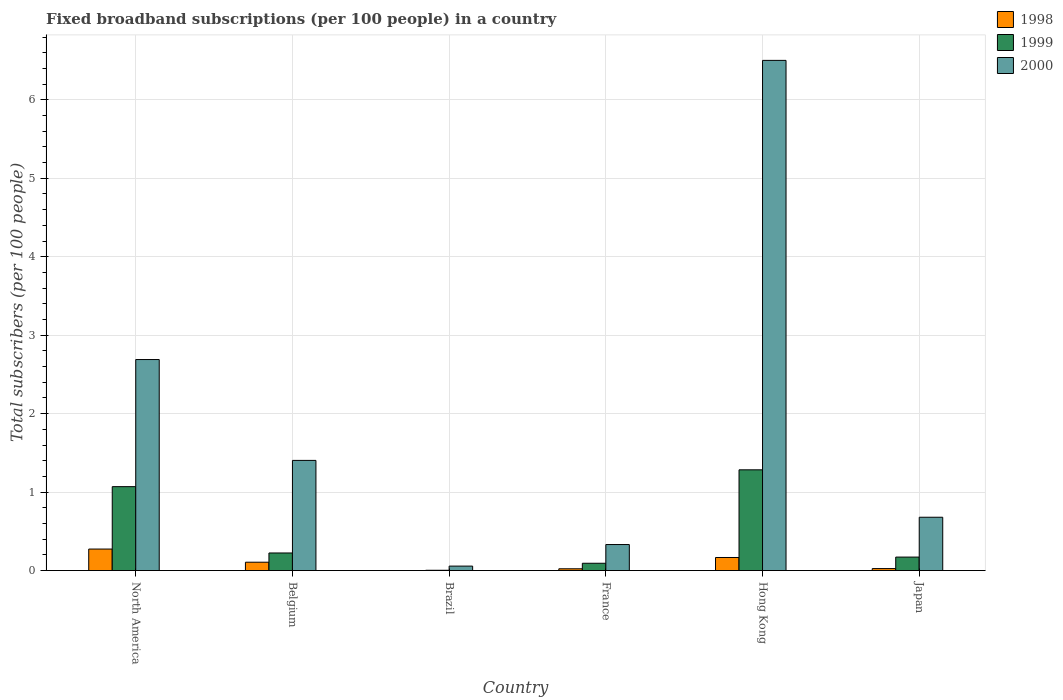Are the number of bars on each tick of the X-axis equal?
Provide a short and direct response. Yes. What is the label of the 5th group of bars from the left?
Offer a terse response. Hong Kong. What is the number of broadband subscriptions in 1999 in France?
Provide a succinct answer. 0.09. Across all countries, what is the maximum number of broadband subscriptions in 2000?
Provide a succinct answer. 6.5. Across all countries, what is the minimum number of broadband subscriptions in 1998?
Offer a terse response. 0. In which country was the number of broadband subscriptions in 2000 maximum?
Keep it short and to the point. Hong Kong. What is the total number of broadband subscriptions in 1999 in the graph?
Offer a terse response. 2.85. What is the difference between the number of broadband subscriptions in 1999 in Belgium and that in Hong Kong?
Ensure brevity in your answer.  -1.06. What is the difference between the number of broadband subscriptions in 1998 in Japan and the number of broadband subscriptions in 1999 in North America?
Your response must be concise. -1.04. What is the average number of broadband subscriptions in 2000 per country?
Make the answer very short. 1.94. What is the difference between the number of broadband subscriptions of/in 2000 and number of broadband subscriptions of/in 1998 in North America?
Give a very brief answer. 2.42. In how many countries, is the number of broadband subscriptions in 1999 greater than 2.2?
Ensure brevity in your answer.  0. What is the ratio of the number of broadband subscriptions in 1998 in Japan to that in North America?
Provide a succinct answer. 0.09. Is the number of broadband subscriptions in 1998 in Belgium less than that in France?
Offer a very short reply. No. What is the difference between the highest and the second highest number of broadband subscriptions in 2000?
Your response must be concise. -1.29. What is the difference between the highest and the lowest number of broadband subscriptions in 1999?
Your answer should be compact. 1.28. In how many countries, is the number of broadband subscriptions in 1999 greater than the average number of broadband subscriptions in 1999 taken over all countries?
Your response must be concise. 2. What does the 3rd bar from the right in Hong Kong represents?
Your response must be concise. 1998. Is it the case that in every country, the sum of the number of broadband subscriptions in 1999 and number of broadband subscriptions in 1998 is greater than the number of broadband subscriptions in 2000?
Your answer should be very brief. No. How many bars are there?
Ensure brevity in your answer.  18. Are all the bars in the graph horizontal?
Keep it short and to the point. No. How many countries are there in the graph?
Make the answer very short. 6. What is the difference between two consecutive major ticks on the Y-axis?
Offer a very short reply. 1. Are the values on the major ticks of Y-axis written in scientific E-notation?
Provide a succinct answer. No. Does the graph contain any zero values?
Ensure brevity in your answer.  No. Where does the legend appear in the graph?
Your answer should be compact. Top right. How are the legend labels stacked?
Your response must be concise. Vertical. What is the title of the graph?
Offer a very short reply. Fixed broadband subscriptions (per 100 people) in a country. What is the label or title of the X-axis?
Provide a short and direct response. Country. What is the label or title of the Y-axis?
Ensure brevity in your answer.  Total subscribers (per 100 people). What is the Total subscribers (per 100 people) of 1998 in North America?
Provide a short and direct response. 0.27. What is the Total subscribers (per 100 people) of 1999 in North America?
Your answer should be compact. 1.07. What is the Total subscribers (per 100 people) in 2000 in North America?
Your answer should be compact. 2.69. What is the Total subscribers (per 100 people) of 1998 in Belgium?
Keep it short and to the point. 0.11. What is the Total subscribers (per 100 people) in 1999 in Belgium?
Give a very brief answer. 0.22. What is the Total subscribers (per 100 people) of 2000 in Belgium?
Ensure brevity in your answer.  1.4. What is the Total subscribers (per 100 people) of 1998 in Brazil?
Your answer should be very brief. 0. What is the Total subscribers (per 100 people) in 1999 in Brazil?
Ensure brevity in your answer.  0. What is the Total subscribers (per 100 people) in 2000 in Brazil?
Provide a short and direct response. 0.06. What is the Total subscribers (per 100 people) in 1998 in France?
Ensure brevity in your answer.  0.02. What is the Total subscribers (per 100 people) in 1999 in France?
Provide a succinct answer. 0.09. What is the Total subscribers (per 100 people) in 2000 in France?
Ensure brevity in your answer.  0.33. What is the Total subscribers (per 100 people) of 1998 in Hong Kong?
Offer a terse response. 0.17. What is the Total subscribers (per 100 people) of 1999 in Hong Kong?
Ensure brevity in your answer.  1.28. What is the Total subscribers (per 100 people) of 2000 in Hong Kong?
Keep it short and to the point. 6.5. What is the Total subscribers (per 100 people) of 1998 in Japan?
Offer a very short reply. 0.03. What is the Total subscribers (per 100 people) in 1999 in Japan?
Provide a short and direct response. 0.17. What is the Total subscribers (per 100 people) in 2000 in Japan?
Your response must be concise. 0.68. Across all countries, what is the maximum Total subscribers (per 100 people) of 1998?
Keep it short and to the point. 0.27. Across all countries, what is the maximum Total subscribers (per 100 people) in 1999?
Keep it short and to the point. 1.28. Across all countries, what is the maximum Total subscribers (per 100 people) of 2000?
Your answer should be compact. 6.5. Across all countries, what is the minimum Total subscribers (per 100 people) of 1998?
Your answer should be very brief. 0. Across all countries, what is the minimum Total subscribers (per 100 people) in 1999?
Your answer should be compact. 0. Across all countries, what is the minimum Total subscribers (per 100 people) in 2000?
Your answer should be compact. 0.06. What is the total Total subscribers (per 100 people) of 1998 in the graph?
Offer a very short reply. 0.6. What is the total Total subscribers (per 100 people) of 1999 in the graph?
Your answer should be very brief. 2.85. What is the total Total subscribers (per 100 people) in 2000 in the graph?
Make the answer very short. 11.67. What is the difference between the Total subscribers (per 100 people) in 1998 in North America and that in Belgium?
Make the answer very short. 0.17. What is the difference between the Total subscribers (per 100 people) of 1999 in North America and that in Belgium?
Your answer should be very brief. 0.85. What is the difference between the Total subscribers (per 100 people) of 2000 in North America and that in Belgium?
Offer a very short reply. 1.29. What is the difference between the Total subscribers (per 100 people) in 1998 in North America and that in Brazil?
Offer a terse response. 0.27. What is the difference between the Total subscribers (per 100 people) in 1999 in North America and that in Brazil?
Make the answer very short. 1.07. What is the difference between the Total subscribers (per 100 people) in 2000 in North America and that in Brazil?
Offer a very short reply. 2.63. What is the difference between the Total subscribers (per 100 people) of 1998 in North America and that in France?
Offer a terse response. 0.25. What is the difference between the Total subscribers (per 100 people) in 1999 in North America and that in France?
Your answer should be very brief. 0.98. What is the difference between the Total subscribers (per 100 people) in 2000 in North America and that in France?
Offer a very short reply. 2.36. What is the difference between the Total subscribers (per 100 people) in 1998 in North America and that in Hong Kong?
Provide a short and direct response. 0.11. What is the difference between the Total subscribers (per 100 people) of 1999 in North America and that in Hong Kong?
Offer a very short reply. -0.21. What is the difference between the Total subscribers (per 100 people) of 2000 in North America and that in Hong Kong?
Your response must be concise. -3.81. What is the difference between the Total subscribers (per 100 people) of 1998 in North America and that in Japan?
Your answer should be compact. 0.25. What is the difference between the Total subscribers (per 100 people) of 1999 in North America and that in Japan?
Ensure brevity in your answer.  0.9. What is the difference between the Total subscribers (per 100 people) in 2000 in North America and that in Japan?
Ensure brevity in your answer.  2.01. What is the difference between the Total subscribers (per 100 people) in 1998 in Belgium and that in Brazil?
Your response must be concise. 0.11. What is the difference between the Total subscribers (per 100 people) of 1999 in Belgium and that in Brazil?
Make the answer very short. 0.22. What is the difference between the Total subscribers (per 100 people) of 2000 in Belgium and that in Brazil?
Ensure brevity in your answer.  1.35. What is the difference between the Total subscribers (per 100 people) in 1998 in Belgium and that in France?
Offer a terse response. 0.08. What is the difference between the Total subscribers (per 100 people) of 1999 in Belgium and that in France?
Offer a very short reply. 0.13. What is the difference between the Total subscribers (per 100 people) in 2000 in Belgium and that in France?
Offer a very short reply. 1.07. What is the difference between the Total subscribers (per 100 people) in 1998 in Belgium and that in Hong Kong?
Your answer should be compact. -0.06. What is the difference between the Total subscribers (per 100 people) of 1999 in Belgium and that in Hong Kong?
Make the answer very short. -1.06. What is the difference between the Total subscribers (per 100 people) of 2000 in Belgium and that in Hong Kong?
Keep it short and to the point. -5.1. What is the difference between the Total subscribers (per 100 people) in 1998 in Belgium and that in Japan?
Provide a short and direct response. 0.08. What is the difference between the Total subscribers (per 100 people) in 1999 in Belgium and that in Japan?
Your answer should be compact. 0.05. What is the difference between the Total subscribers (per 100 people) of 2000 in Belgium and that in Japan?
Offer a very short reply. 0.72. What is the difference between the Total subscribers (per 100 people) in 1998 in Brazil and that in France?
Offer a terse response. -0.02. What is the difference between the Total subscribers (per 100 people) of 1999 in Brazil and that in France?
Give a very brief answer. -0.09. What is the difference between the Total subscribers (per 100 people) in 2000 in Brazil and that in France?
Your response must be concise. -0.27. What is the difference between the Total subscribers (per 100 people) of 1998 in Brazil and that in Hong Kong?
Your answer should be very brief. -0.17. What is the difference between the Total subscribers (per 100 people) of 1999 in Brazil and that in Hong Kong?
Give a very brief answer. -1.28. What is the difference between the Total subscribers (per 100 people) in 2000 in Brazil and that in Hong Kong?
Provide a short and direct response. -6.45. What is the difference between the Total subscribers (per 100 people) in 1998 in Brazil and that in Japan?
Your response must be concise. -0.03. What is the difference between the Total subscribers (per 100 people) of 1999 in Brazil and that in Japan?
Keep it short and to the point. -0.17. What is the difference between the Total subscribers (per 100 people) of 2000 in Brazil and that in Japan?
Offer a very short reply. -0.62. What is the difference between the Total subscribers (per 100 people) in 1998 in France and that in Hong Kong?
Provide a succinct answer. -0.14. What is the difference between the Total subscribers (per 100 people) of 1999 in France and that in Hong Kong?
Offer a very short reply. -1.19. What is the difference between the Total subscribers (per 100 people) in 2000 in France and that in Hong Kong?
Your answer should be compact. -6.17. What is the difference between the Total subscribers (per 100 people) of 1998 in France and that in Japan?
Keep it short and to the point. -0. What is the difference between the Total subscribers (per 100 people) of 1999 in France and that in Japan?
Your answer should be compact. -0.08. What is the difference between the Total subscribers (per 100 people) in 2000 in France and that in Japan?
Offer a very short reply. -0.35. What is the difference between the Total subscribers (per 100 people) in 1998 in Hong Kong and that in Japan?
Your answer should be compact. 0.14. What is the difference between the Total subscribers (per 100 people) in 1999 in Hong Kong and that in Japan?
Give a very brief answer. 1.11. What is the difference between the Total subscribers (per 100 people) in 2000 in Hong Kong and that in Japan?
Your answer should be compact. 5.82. What is the difference between the Total subscribers (per 100 people) of 1998 in North America and the Total subscribers (per 100 people) of 1999 in Belgium?
Your answer should be very brief. 0.05. What is the difference between the Total subscribers (per 100 people) in 1998 in North America and the Total subscribers (per 100 people) in 2000 in Belgium?
Your response must be concise. -1.13. What is the difference between the Total subscribers (per 100 people) of 1999 in North America and the Total subscribers (per 100 people) of 2000 in Belgium?
Keep it short and to the point. -0.33. What is the difference between the Total subscribers (per 100 people) of 1998 in North America and the Total subscribers (per 100 people) of 1999 in Brazil?
Your answer should be compact. 0.27. What is the difference between the Total subscribers (per 100 people) in 1998 in North America and the Total subscribers (per 100 people) in 2000 in Brazil?
Your answer should be compact. 0.22. What is the difference between the Total subscribers (per 100 people) in 1999 in North America and the Total subscribers (per 100 people) in 2000 in Brazil?
Provide a short and direct response. 1.01. What is the difference between the Total subscribers (per 100 people) of 1998 in North America and the Total subscribers (per 100 people) of 1999 in France?
Give a very brief answer. 0.18. What is the difference between the Total subscribers (per 100 people) of 1998 in North America and the Total subscribers (per 100 people) of 2000 in France?
Your answer should be very brief. -0.06. What is the difference between the Total subscribers (per 100 people) of 1999 in North America and the Total subscribers (per 100 people) of 2000 in France?
Offer a very short reply. 0.74. What is the difference between the Total subscribers (per 100 people) in 1998 in North America and the Total subscribers (per 100 people) in 1999 in Hong Kong?
Keep it short and to the point. -1.01. What is the difference between the Total subscribers (per 100 people) of 1998 in North America and the Total subscribers (per 100 people) of 2000 in Hong Kong?
Offer a terse response. -6.23. What is the difference between the Total subscribers (per 100 people) in 1999 in North America and the Total subscribers (per 100 people) in 2000 in Hong Kong?
Give a very brief answer. -5.43. What is the difference between the Total subscribers (per 100 people) of 1998 in North America and the Total subscribers (per 100 people) of 1999 in Japan?
Your answer should be compact. 0.1. What is the difference between the Total subscribers (per 100 people) in 1998 in North America and the Total subscribers (per 100 people) in 2000 in Japan?
Offer a terse response. -0.41. What is the difference between the Total subscribers (per 100 people) of 1999 in North America and the Total subscribers (per 100 people) of 2000 in Japan?
Your response must be concise. 0.39. What is the difference between the Total subscribers (per 100 people) of 1998 in Belgium and the Total subscribers (per 100 people) of 1999 in Brazil?
Give a very brief answer. 0.1. What is the difference between the Total subscribers (per 100 people) of 1998 in Belgium and the Total subscribers (per 100 people) of 2000 in Brazil?
Your answer should be compact. 0.05. What is the difference between the Total subscribers (per 100 people) in 1999 in Belgium and the Total subscribers (per 100 people) in 2000 in Brazil?
Keep it short and to the point. 0.17. What is the difference between the Total subscribers (per 100 people) in 1998 in Belgium and the Total subscribers (per 100 people) in 1999 in France?
Your answer should be very brief. 0.01. What is the difference between the Total subscribers (per 100 people) in 1998 in Belgium and the Total subscribers (per 100 people) in 2000 in France?
Offer a terse response. -0.23. What is the difference between the Total subscribers (per 100 people) of 1999 in Belgium and the Total subscribers (per 100 people) of 2000 in France?
Ensure brevity in your answer.  -0.11. What is the difference between the Total subscribers (per 100 people) in 1998 in Belgium and the Total subscribers (per 100 people) in 1999 in Hong Kong?
Your answer should be very brief. -1.18. What is the difference between the Total subscribers (per 100 people) in 1998 in Belgium and the Total subscribers (per 100 people) in 2000 in Hong Kong?
Your answer should be compact. -6.4. What is the difference between the Total subscribers (per 100 people) of 1999 in Belgium and the Total subscribers (per 100 people) of 2000 in Hong Kong?
Your response must be concise. -6.28. What is the difference between the Total subscribers (per 100 people) in 1998 in Belgium and the Total subscribers (per 100 people) in 1999 in Japan?
Your response must be concise. -0.07. What is the difference between the Total subscribers (per 100 people) in 1998 in Belgium and the Total subscribers (per 100 people) in 2000 in Japan?
Make the answer very short. -0.57. What is the difference between the Total subscribers (per 100 people) in 1999 in Belgium and the Total subscribers (per 100 people) in 2000 in Japan?
Provide a short and direct response. -0.46. What is the difference between the Total subscribers (per 100 people) in 1998 in Brazil and the Total subscribers (per 100 people) in 1999 in France?
Keep it short and to the point. -0.09. What is the difference between the Total subscribers (per 100 people) in 1998 in Brazil and the Total subscribers (per 100 people) in 2000 in France?
Your answer should be compact. -0.33. What is the difference between the Total subscribers (per 100 people) in 1999 in Brazil and the Total subscribers (per 100 people) in 2000 in France?
Ensure brevity in your answer.  -0.33. What is the difference between the Total subscribers (per 100 people) in 1998 in Brazil and the Total subscribers (per 100 people) in 1999 in Hong Kong?
Make the answer very short. -1.28. What is the difference between the Total subscribers (per 100 people) of 1998 in Brazil and the Total subscribers (per 100 people) of 2000 in Hong Kong?
Give a very brief answer. -6.5. What is the difference between the Total subscribers (per 100 people) of 1999 in Brazil and the Total subscribers (per 100 people) of 2000 in Hong Kong?
Offer a terse response. -6.5. What is the difference between the Total subscribers (per 100 people) in 1998 in Brazil and the Total subscribers (per 100 people) in 1999 in Japan?
Keep it short and to the point. -0.17. What is the difference between the Total subscribers (per 100 people) in 1998 in Brazil and the Total subscribers (per 100 people) in 2000 in Japan?
Offer a terse response. -0.68. What is the difference between the Total subscribers (per 100 people) in 1999 in Brazil and the Total subscribers (per 100 people) in 2000 in Japan?
Your response must be concise. -0.68. What is the difference between the Total subscribers (per 100 people) in 1998 in France and the Total subscribers (per 100 people) in 1999 in Hong Kong?
Provide a succinct answer. -1.26. What is the difference between the Total subscribers (per 100 people) in 1998 in France and the Total subscribers (per 100 people) in 2000 in Hong Kong?
Offer a very short reply. -6.48. What is the difference between the Total subscribers (per 100 people) of 1999 in France and the Total subscribers (per 100 people) of 2000 in Hong Kong?
Give a very brief answer. -6.41. What is the difference between the Total subscribers (per 100 people) of 1998 in France and the Total subscribers (per 100 people) of 1999 in Japan?
Your answer should be very brief. -0.15. What is the difference between the Total subscribers (per 100 people) of 1998 in France and the Total subscribers (per 100 people) of 2000 in Japan?
Your answer should be very brief. -0.66. What is the difference between the Total subscribers (per 100 people) of 1999 in France and the Total subscribers (per 100 people) of 2000 in Japan?
Your answer should be very brief. -0.59. What is the difference between the Total subscribers (per 100 people) of 1998 in Hong Kong and the Total subscribers (per 100 people) of 1999 in Japan?
Provide a short and direct response. -0.01. What is the difference between the Total subscribers (per 100 people) of 1998 in Hong Kong and the Total subscribers (per 100 people) of 2000 in Japan?
Your answer should be very brief. -0.51. What is the difference between the Total subscribers (per 100 people) in 1999 in Hong Kong and the Total subscribers (per 100 people) in 2000 in Japan?
Give a very brief answer. 0.6. What is the average Total subscribers (per 100 people) of 1998 per country?
Keep it short and to the point. 0.1. What is the average Total subscribers (per 100 people) in 1999 per country?
Your answer should be very brief. 0.47. What is the average Total subscribers (per 100 people) in 2000 per country?
Your answer should be compact. 1.94. What is the difference between the Total subscribers (per 100 people) of 1998 and Total subscribers (per 100 people) of 1999 in North America?
Provide a short and direct response. -0.8. What is the difference between the Total subscribers (per 100 people) in 1998 and Total subscribers (per 100 people) in 2000 in North America?
Offer a terse response. -2.42. What is the difference between the Total subscribers (per 100 people) in 1999 and Total subscribers (per 100 people) in 2000 in North America?
Ensure brevity in your answer.  -1.62. What is the difference between the Total subscribers (per 100 people) of 1998 and Total subscribers (per 100 people) of 1999 in Belgium?
Provide a succinct answer. -0.12. What is the difference between the Total subscribers (per 100 people) of 1998 and Total subscribers (per 100 people) of 2000 in Belgium?
Give a very brief answer. -1.3. What is the difference between the Total subscribers (per 100 people) in 1999 and Total subscribers (per 100 people) in 2000 in Belgium?
Give a very brief answer. -1.18. What is the difference between the Total subscribers (per 100 people) in 1998 and Total subscribers (per 100 people) in 1999 in Brazil?
Your response must be concise. -0. What is the difference between the Total subscribers (per 100 people) in 1998 and Total subscribers (per 100 people) in 2000 in Brazil?
Give a very brief answer. -0.06. What is the difference between the Total subscribers (per 100 people) in 1999 and Total subscribers (per 100 people) in 2000 in Brazil?
Provide a short and direct response. -0.05. What is the difference between the Total subscribers (per 100 people) in 1998 and Total subscribers (per 100 people) in 1999 in France?
Your response must be concise. -0.07. What is the difference between the Total subscribers (per 100 people) of 1998 and Total subscribers (per 100 people) of 2000 in France?
Offer a terse response. -0.31. What is the difference between the Total subscribers (per 100 people) in 1999 and Total subscribers (per 100 people) in 2000 in France?
Your answer should be compact. -0.24. What is the difference between the Total subscribers (per 100 people) in 1998 and Total subscribers (per 100 people) in 1999 in Hong Kong?
Your answer should be very brief. -1.12. What is the difference between the Total subscribers (per 100 people) of 1998 and Total subscribers (per 100 people) of 2000 in Hong Kong?
Offer a terse response. -6.34. What is the difference between the Total subscribers (per 100 people) in 1999 and Total subscribers (per 100 people) in 2000 in Hong Kong?
Your response must be concise. -5.22. What is the difference between the Total subscribers (per 100 people) of 1998 and Total subscribers (per 100 people) of 1999 in Japan?
Make the answer very short. -0.15. What is the difference between the Total subscribers (per 100 people) in 1998 and Total subscribers (per 100 people) in 2000 in Japan?
Your answer should be very brief. -0.65. What is the difference between the Total subscribers (per 100 people) of 1999 and Total subscribers (per 100 people) of 2000 in Japan?
Ensure brevity in your answer.  -0.51. What is the ratio of the Total subscribers (per 100 people) in 1998 in North America to that in Belgium?
Keep it short and to the point. 2.57. What is the ratio of the Total subscribers (per 100 people) in 1999 in North America to that in Belgium?
Offer a very short reply. 4.76. What is the ratio of the Total subscribers (per 100 people) of 2000 in North America to that in Belgium?
Offer a terse response. 1.92. What is the ratio of the Total subscribers (per 100 people) of 1998 in North America to that in Brazil?
Provide a short and direct response. 465.15. What is the ratio of the Total subscribers (per 100 people) of 1999 in North America to that in Brazil?
Provide a succinct answer. 262.9. What is the ratio of the Total subscribers (per 100 people) of 2000 in North America to that in Brazil?
Offer a terse response. 46.94. What is the ratio of the Total subscribers (per 100 people) in 1998 in North America to that in France?
Keep it short and to the point. 11.95. What is the ratio of the Total subscribers (per 100 people) of 1999 in North America to that in France?
Give a very brief answer. 11.46. What is the ratio of the Total subscribers (per 100 people) of 2000 in North America to that in France?
Your response must be concise. 8.1. What is the ratio of the Total subscribers (per 100 people) of 1998 in North America to that in Hong Kong?
Ensure brevity in your answer.  1.64. What is the ratio of the Total subscribers (per 100 people) of 1999 in North America to that in Hong Kong?
Make the answer very short. 0.83. What is the ratio of the Total subscribers (per 100 people) of 2000 in North America to that in Hong Kong?
Provide a short and direct response. 0.41. What is the ratio of the Total subscribers (per 100 people) of 1998 in North America to that in Japan?
Your answer should be very brief. 10.74. What is the ratio of the Total subscribers (per 100 people) in 1999 in North America to that in Japan?
Make the answer very short. 6.22. What is the ratio of the Total subscribers (per 100 people) of 2000 in North America to that in Japan?
Your response must be concise. 3.96. What is the ratio of the Total subscribers (per 100 people) in 1998 in Belgium to that in Brazil?
Give a very brief answer. 181.1. What is the ratio of the Total subscribers (per 100 people) of 1999 in Belgium to that in Brazil?
Provide a short and direct response. 55.18. What is the ratio of the Total subscribers (per 100 people) in 2000 in Belgium to that in Brazil?
Your response must be concise. 24.51. What is the ratio of the Total subscribers (per 100 people) of 1998 in Belgium to that in France?
Your answer should be compact. 4.65. What is the ratio of the Total subscribers (per 100 people) of 1999 in Belgium to that in France?
Make the answer very short. 2.4. What is the ratio of the Total subscribers (per 100 people) of 2000 in Belgium to that in France?
Provide a short and direct response. 4.23. What is the ratio of the Total subscribers (per 100 people) in 1998 in Belgium to that in Hong Kong?
Offer a very short reply. 0.64. What is the ratio of the Total subscribers (per 100 people) of 1999 in Belgium to that in Hong Kong?
Your answer should be very brief. 0.17. What is the ratio of the Total subscribers (per 100 people) of 2000 in Belgium to that in Hong Kong?
Offer a terse response. 0.22. What is the ratio of the Total subscribers (per 100 people) in 1998 in Belgium to that in Japan?
Offer a terse response. 4.18. What is the ratio of the Total subscribers (per 100 people) of 1999 in Belgium to that in Japan?
Offer a terse response. 1.3. What is the ratio of the Total subscribers (per 100 people) of 2000 in Belgium to that in Japan?
Offer a terse response. 2.07. What is the ratio of the Total subscribers (per 100 people) of 1998 in Brazil to that in France?
Keep it short and to the point. 0.03. What is the ratio of the Total subscribers (per 100 people) of 1999 in Brazil to that in France?
Offer a terse response. 0.04. What is the ratio of the Total subscribers (per 100 people) in 2000 in Brazil to that in France?
Make the answer very short. 0.17. What is the ratio of the Total subscribers (per 100 people) of 1998 in Brazil to that in Hong Kong?
Keep it short and to the point. 0. What is the ratio of the Total subscribers (per 100 people) in 1999 in Brazil to that in Hong Kong?
Give a very brief answer. 0. What is the ratio of the Total subscribers (per 100 people) of 2000 in Brazil to that in Hong Kong?
Provide a succinct answer. 0.01. What is the ratio of the Total subscribers (per 100 people) in 1998 in Brazil to that in Japan?
Give a very brief answer. 0.02. What is the ratio of the Total subscribers (per 100 people) in 1999 in Brazil to that in Japan?
Ensure brevity in your answer.  0.02. What is the ratio of the Total subscribers (per 100 people) of 2000 in Brazil to that in Japan?
Your answer should be very brief. 0.08. What is the ratio of the Total subscribers (per 100 people) in 1998 in France to that in Hong Kong?
Your response must be concise. 0.14. What is the ratio of the Total subscribers (per 100 people) in 1999 in France to that in Hong Kong?
Your answer should be compact. 0.07. What is the ratio of the Total subscribers (per 100 people) in 2000 in France to that in Hong Kong?
Your response must be concise. 0.05. What is the ratio of the Total subscribers (per 100 people) in 1998 in France to that in Japan?
Keep it short and to the point. 0.9. What is the ratio of the Total subscribers (per 100 people) in 1999 in France to that in Japan?
Provide a succinct answer. 0.54. What is the ratio of the Total subscribers (per 100 people) of 2000 in France to that in Japan?
Keep it short and to the point. 0.49. What is the ratio of the Total subscribers (per 100 people) of 1998 in Hong Kong to that in Japan?
Ensure brevity in your answer.  6.53. What is the ratio of the Total subscribers (per 100 people) in 1999 in Hong Kong to that in Japan?
Your response must be concise. 7.46. What is the ratio of the Total subscribers (per 100 people) of 2000 in Hong Kong to that in Japan?
Your response must be concise. 9.56. What is the difference between the highest and the second highest Total subscribers (per 100 people) in 1998?
Offer a terse response. 0.11. What is the difference between the highest and the second highest Total subscribers (per 100 people) of 1999?
Your answer should be compact. 0.21. What is the difference between the highest and the second highest Total subscribers (per 100 people) in 2000?
Offer a very short reply. 3.81. What is the difference between the highest and the lowest Total subscribers (per 100 people) of 1998?
Your response must be concise. 0.27. What is the difference between the highest and the lowest Total subscribers (per 100 people) in 1999?
Your answer should be compact. 1.28. What is the difference between the highest and the lowest Total subscribers (per 100 people) in 2000?
Give a very brief answer. 6.45. 